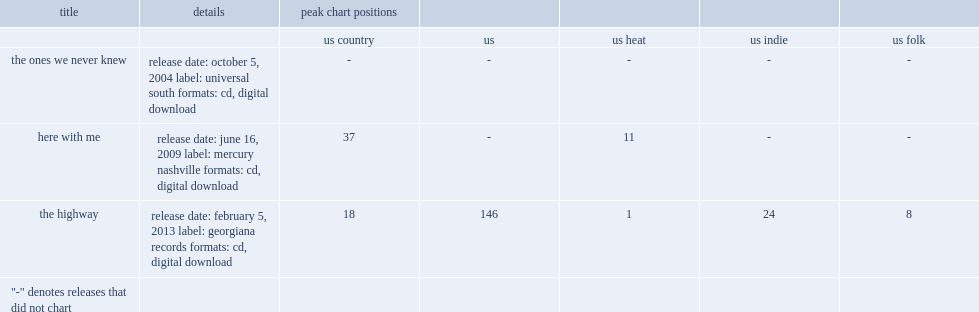What is the highway's peak chart position in the us ? 146.0. Help me parse the entirety of this table. {'header': ['title', 'details', 'peak chart positions', '', '', '', ''], 'rows': [['', '', 'us country', 'us', 'us heat', 'us indie', 'us folk'], ['the ones we never knew', 'release date: october 5, 2004 label: universal south formats: cd, digital download', '-', '-', '-', '-', '-'], ['here with me', 'release date: june 16, 2009 label: mercury nashville formats: cd, digital download', '37', '-', '11', '-', '-'], ['the highway', 'release date: february 5, 2013 label: georgiana records formats: cd, digital download', '18', '146', '1', '24', '8'], ['"-" denotes releases that did not chart', '', '', '', '', '', '']]} 